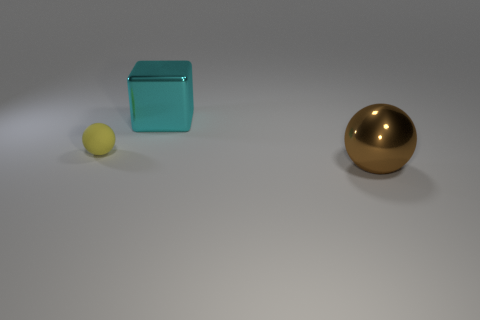Add 3 small red metallic cylinders. How many objects exist? 6 Subtract all spheres. How many objects are left? 1 Add 3 yellow things. How many yellow things exist? 4 Subtract 0 green cubes. How many objects are left? 3 Subtract all large things. Subtract all tiny rubber spheres. How many objects are left? 0 Add 1 tiny yellow matte spheres. How many tiny yellow matte spheres are left? 2 